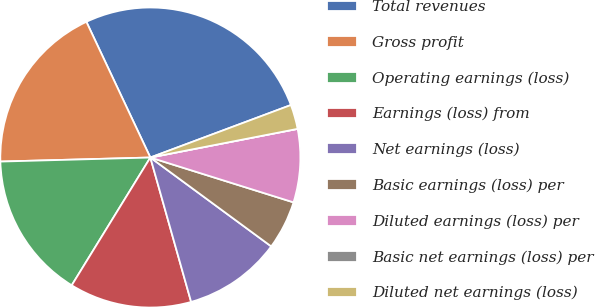<chart> <loc_0><loc_0><loc_500><loc_500><pie_chart><fcel>Total revenues<fcel>Gross profit<fcel>Operating earnings (loss)<fcel>Earnings (loss) from<fcel>Net earnings (loss)<fcel>Basic earnings (loss) per<fcel>Diluted earnings (loss) per<fcel>Basic net earnings (loss) per<fcel>Diluted net earnings (loss)<nl><fcel>26.32%<fcel>18.42%<fcel>15.79%<fcel>13.16%<fcel>10.53%<fcel>5.26%<fcel>7.89%<fcel>0.0%<fcel>2.63%<nl></chart> 